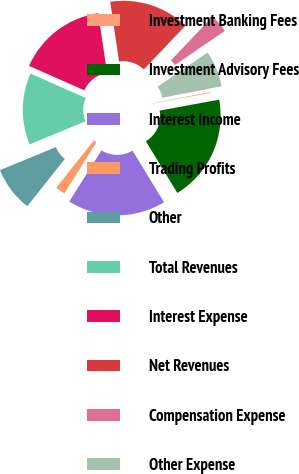Convert chart. <chart><loc_0><loc_0><loc_500><loc_500><pie_chart><fcel>Investment Banking Fees<fcel>Investment Advisory Fees<fcel>Interest Income<fcel>Trading Profits<fcel>Other<fcel>Total Revenues<fcel>Interest Expense<fcel>Net Revenues<fcel>Compensation Expense<fcel>Other Expense<nl><fcel>0.15%<fcel>19.21%<fcel>17.62%<fcel>1.74%<fcel>8.09%<fcel>12.86%<fcel>16.04%<fcel>14.45%<fcel>3.33%<fcel>6.51%<nl></chart> 